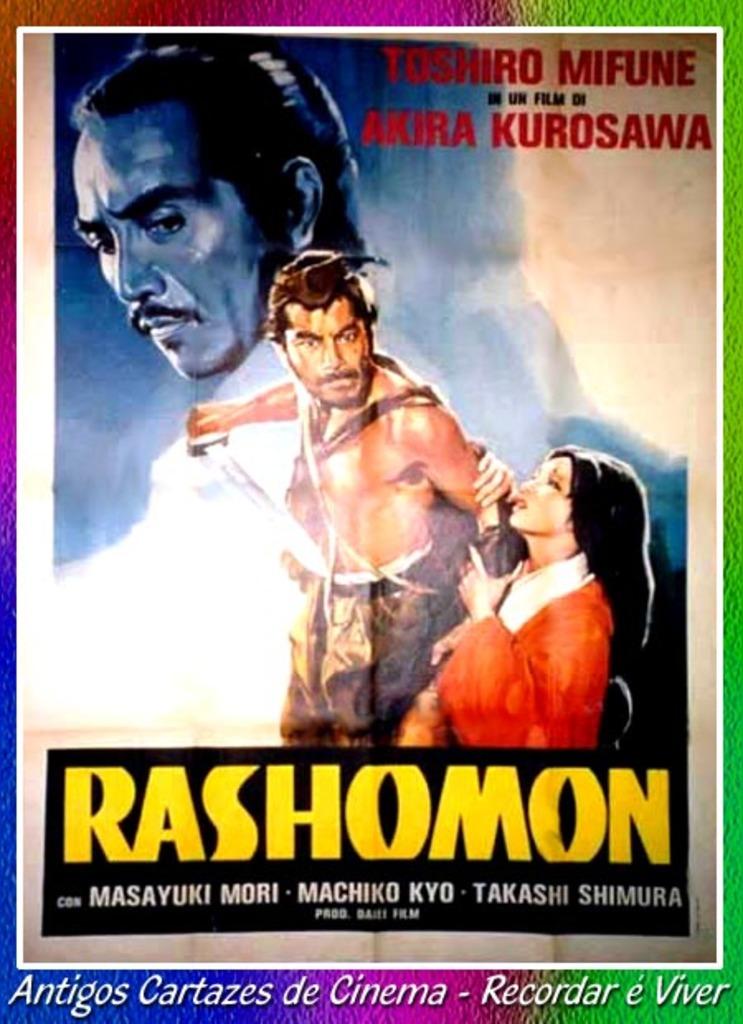What does the yellow text say?
Your response must be concise. Rashomon. Who made this movie?
Your answer should be very brief. Akira kurosawa. 